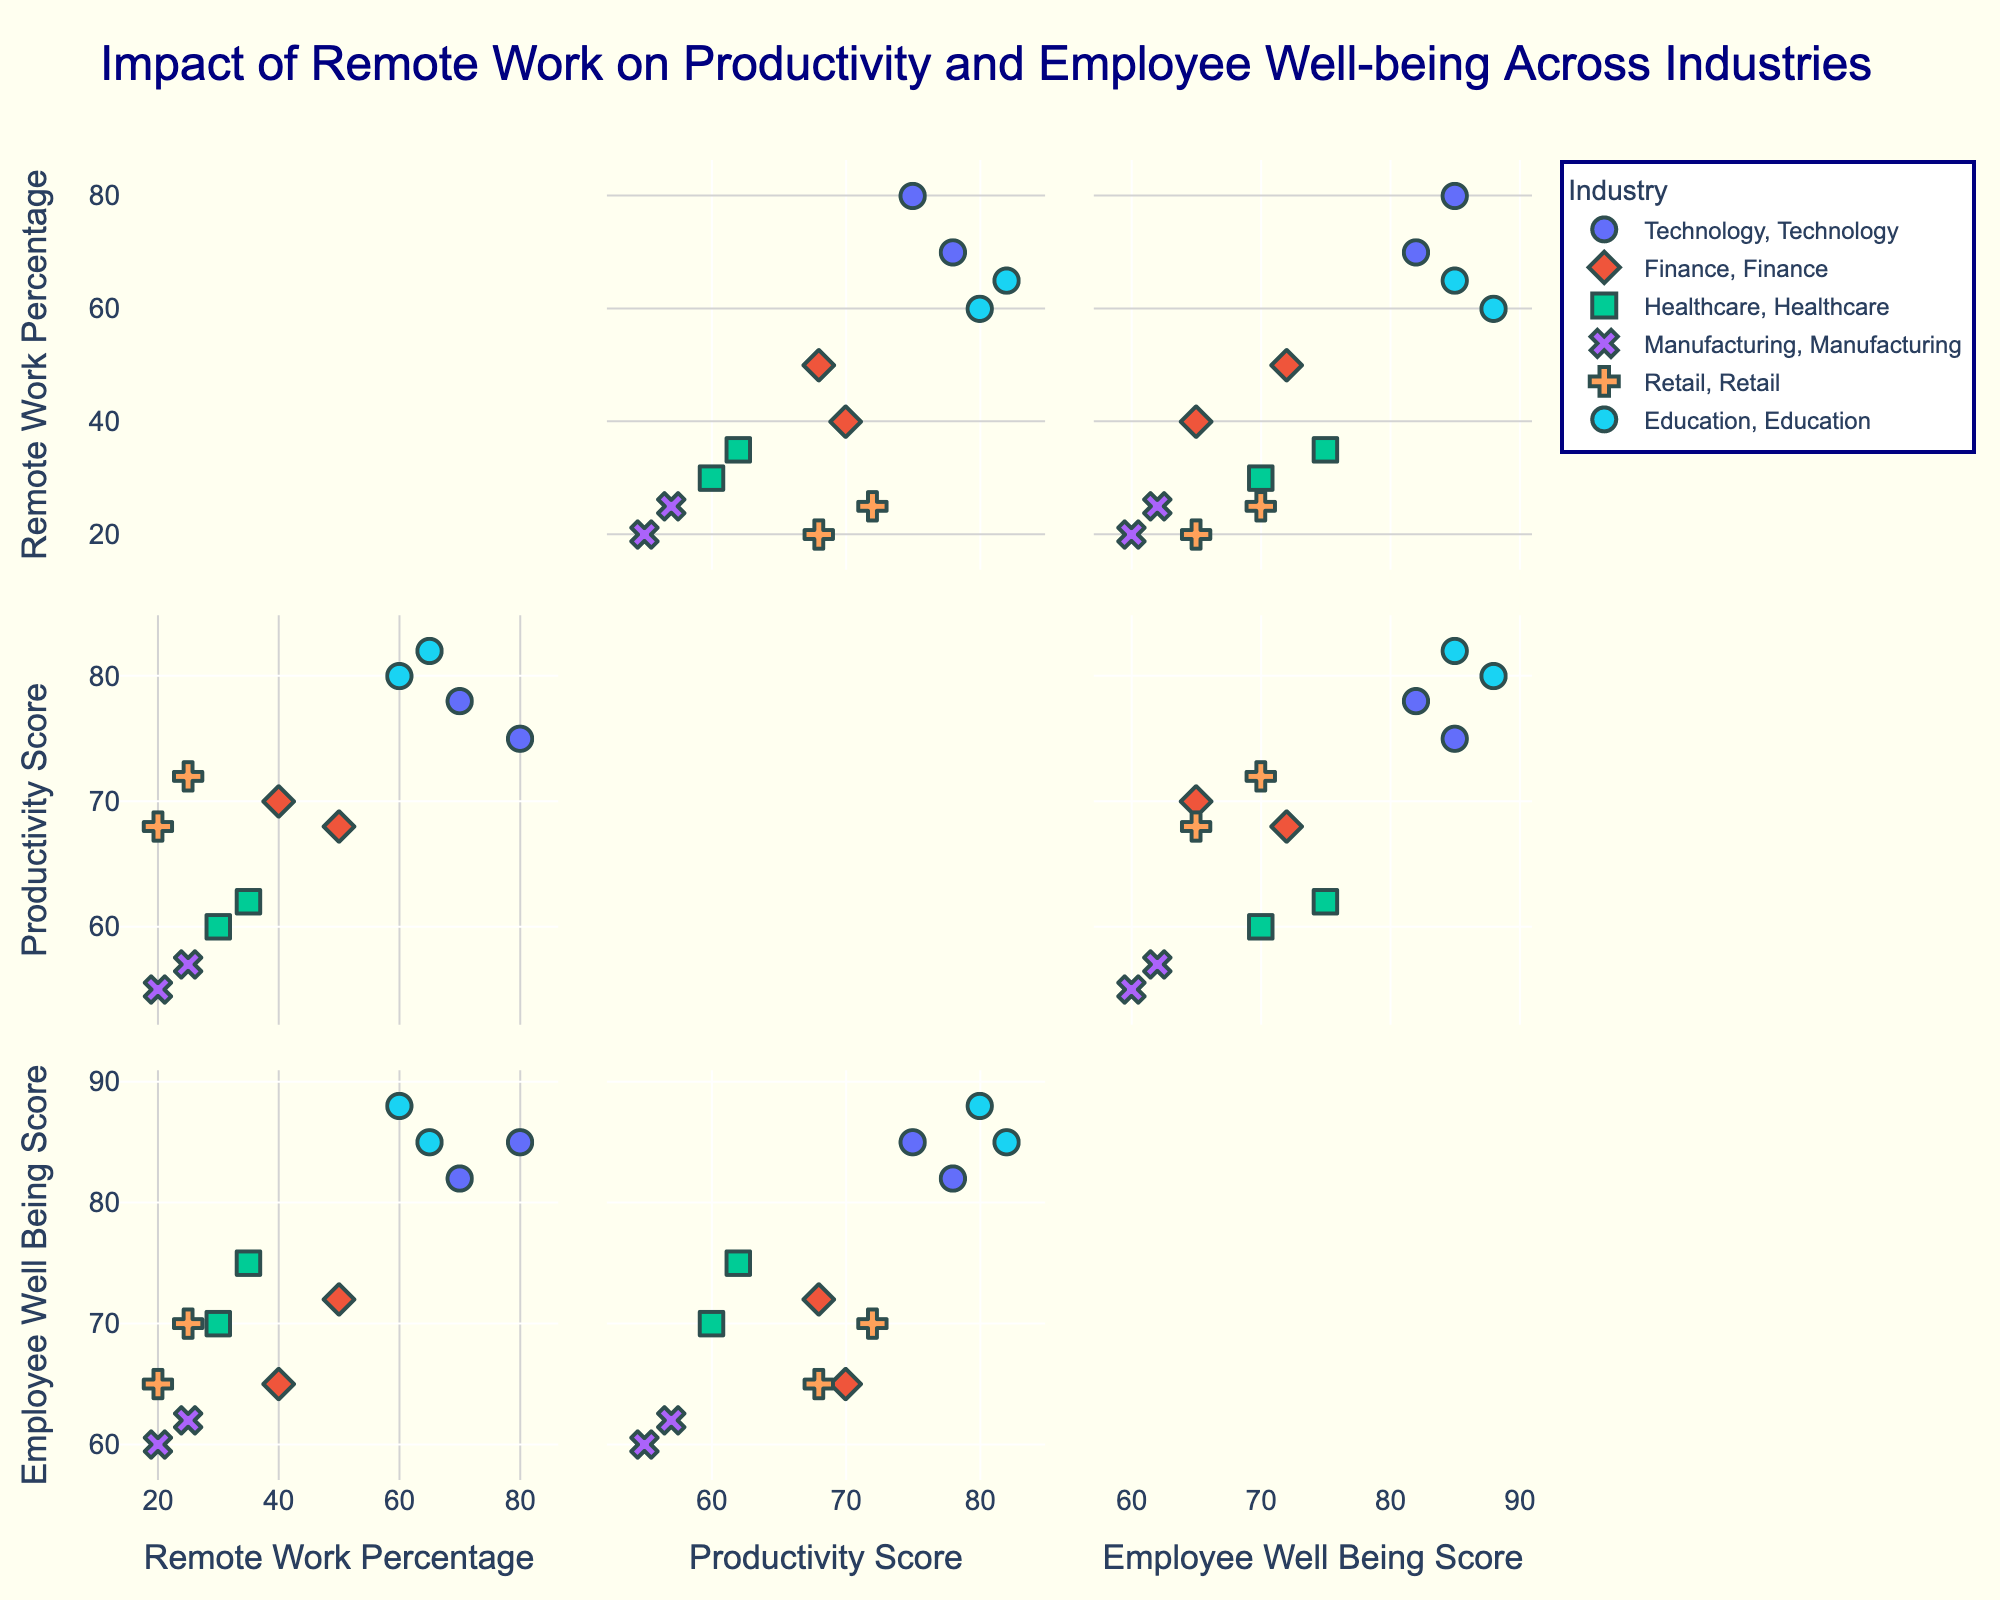What is the title of the figure? The title of the figure is usually displayed at the top and provides a summary of what the plot is depicting.
Answer: Impact of Remote Work on Productivity and Employee Well-being Across Various Industries How many unique industries are displayed in the scatter plot matrix? Each unique industry likely has a unique color and/or symbol, indicated in the legend. Counting them will give the total number of unique industries.
Answer: 5 Which industry has the highest productivity score, and what is that score? By looking at the plot that correlates 'Productivity Score' with different industries, identify the highest data point. The title of the industry can be detected by its color or symbol.
Answer: Education, 82 For the Finance industry, what is the average Remote Work Percentage? Identify the Remote Work Percentage values for all companies in the Finance industry and calculate the average. For JPMorgan Chase (50) and Goldman Sachs (40), sum them and divide by 2. (50 + 40) / 2 = 45.
Answer: 45 Does any industry show a positive correlation between Remote Work Percentage and Employee Well-being Score? By observing the scatter plots of 'Remote Work Percentage' vs. 'Employee Well-being Score,' note the trends for each industry. A positive correlation trends upwards.
Answer: Education Which company has the lowest Employee Well-being score, and what is that score? Look at the 'Employee Well-being Score' axis and find the lowest data point. Identify the company and score from the legend.
Answer: Goldman Sachs, 65 What is the range of Remote Work Percentages for the Retail industry? Find the minimum and maximum 'Remote Work Percentage' values within the Retail industry data points. The range is the difference between these values. For Amazon (25) and Walmart (20), the range is 25 - 20 = 5.
Answer: 5 Compare the Productivity Scores between Technology and Manufacturing industries: which industry shows higher scores on average? Calculate the average Productivity Score for each industry by summing the scores and dividing by the number of companies in each industry. Technology (75 + 78) / 2 = 76.5 and Manufacturing (55 + 57) / 2 = 56; compare these values.
Answer: Technology, 76.5 Is there a company that has both high productivity and high employee well-being scores? If so, name it. Identify the top data points in both 'Productivity Score' and 'Employee Well-being Score' plots. The company in both top positions represents high values in both aspects.
Answer: Stanford University What's the correlation pattern between Remote Work Percentage and Productivity Score for the Healthcare industry? Look at the scatter plot for Healthcare between 'Remote Work Percentage' and 'Productivity Score.' Determine whether the points trend upwards, downwards, or show no clear pattern.
Answer: No clear pattern 